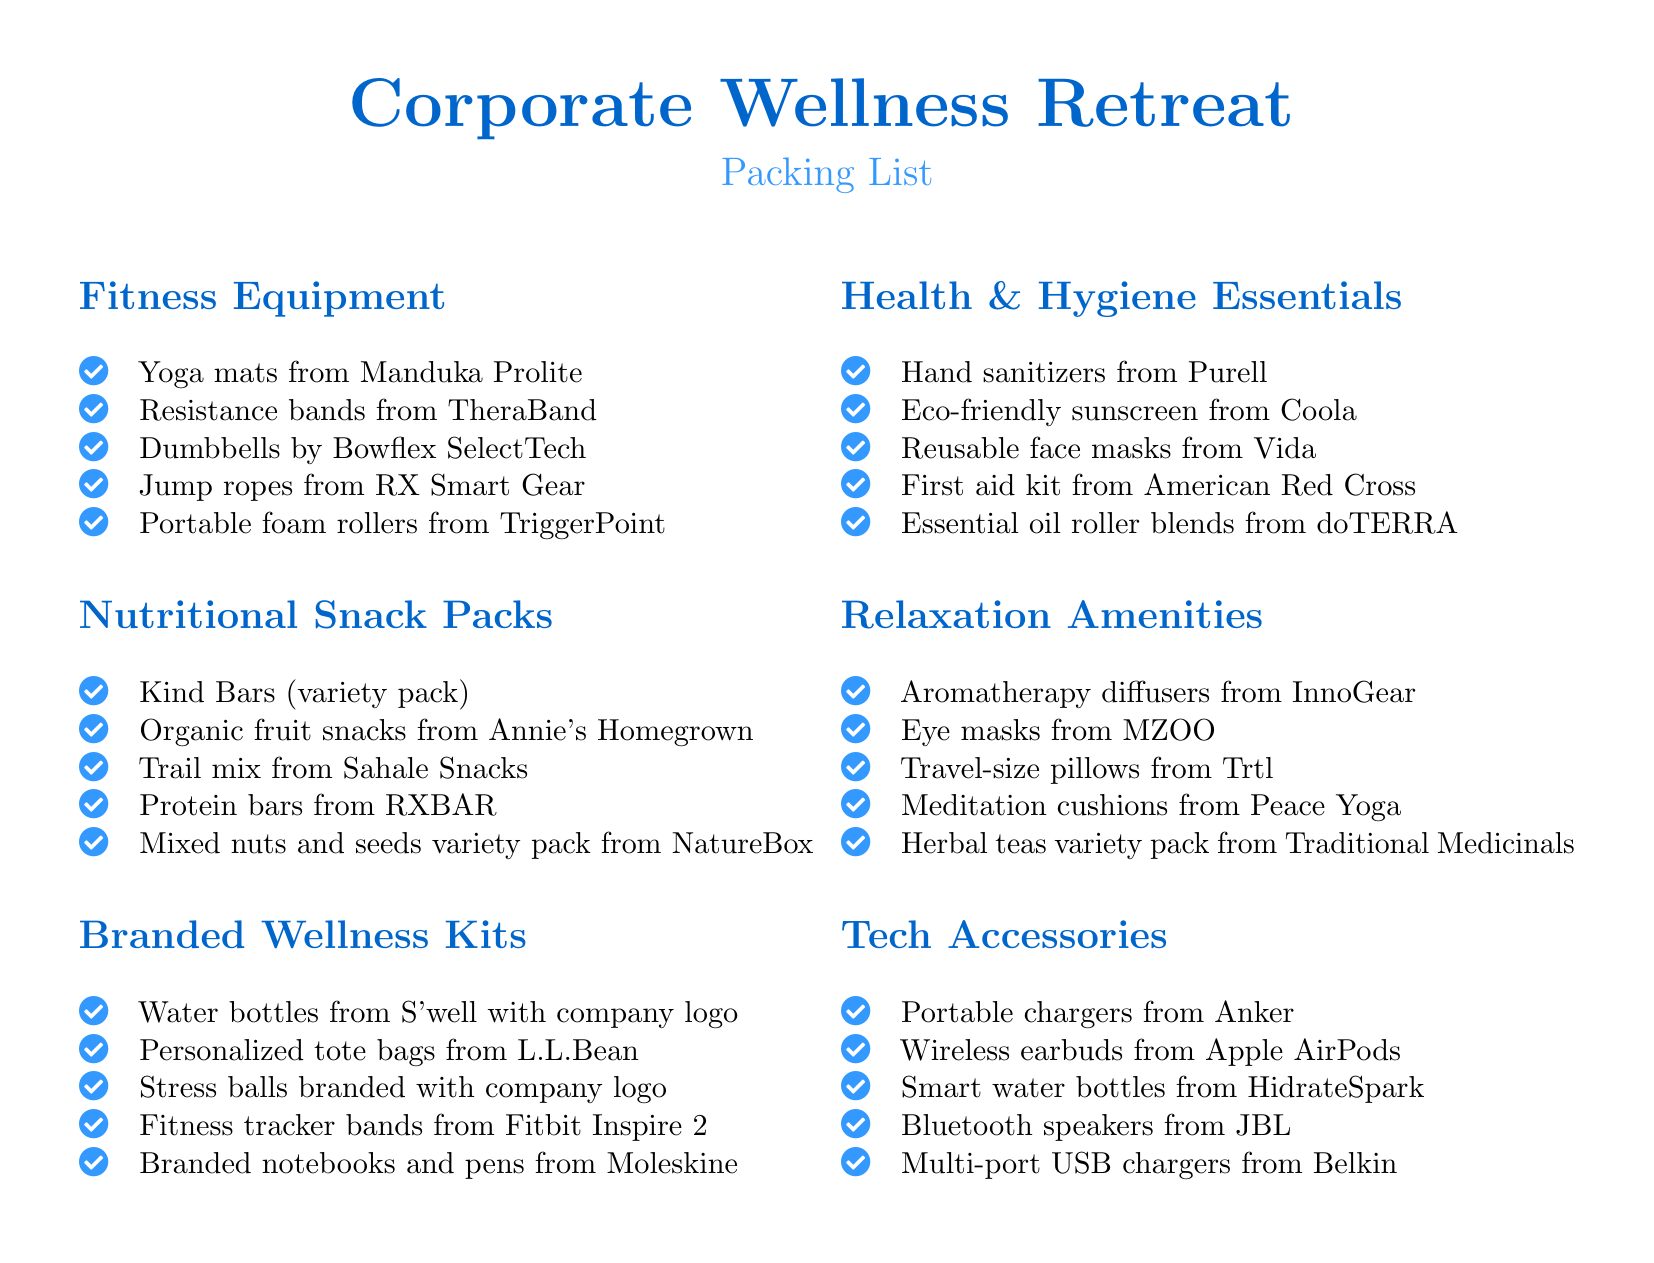What are the types of fitness equipment listed? The document specifies several types of fitness equipment such as yoga mats, resistance bands, dumbbells, jump ropes, and foam rollers.
Answer: Yoga mats, resistance bands, dumbbells, jump ropes, foam rollers How many nutritional snack pack items are listed? The document contains five items under the nutritional snack packs section.
Answer: 5 What is included in the branded wellness kits? The branded wellness kits include items like water bottles, personalized tote bags, stress balls, fitness tracker bands, and branded notebooks.
Answer: Water bottles, personalized tote bags, stress balls, fitness tracker bands, branded notebooks Which brand is mentioned for portable chargers? The portable chargers are specified to be from the brand Anker.
Answer: Anker What product is listed for health and hygiene essentials? The health and hygiene essentials include various items such as hand sanitizers, eco-friendly sunscreen, and reusable face masks.
Answer: Hand sanitizers, eco-friendly sunscreen, reusable face masks What section in the document includes meditation cushions? Meditation cushions are mentioned in the relaxation amenities section.
Answer: Relaxation Amenities What type of speakers are listed under tech accessories? The document lists Bluetooth speakers under the tech accessories category.
Answer: Bluetooth speakers How many items are in the relaxation amenities section? There are five items listed in the relaxation amenities section of the document.
Answer: 5 Which company produced the resistance bands mentioned? The resistance bands included in the fitness equipment section are from TheraBand.
Answer: TheraBand 